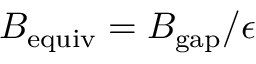<formula> <loc_0><loc_0><loc_500><loc_500>B _ { e q u i v } = B _ { g a p } / \epsilon</formula> 